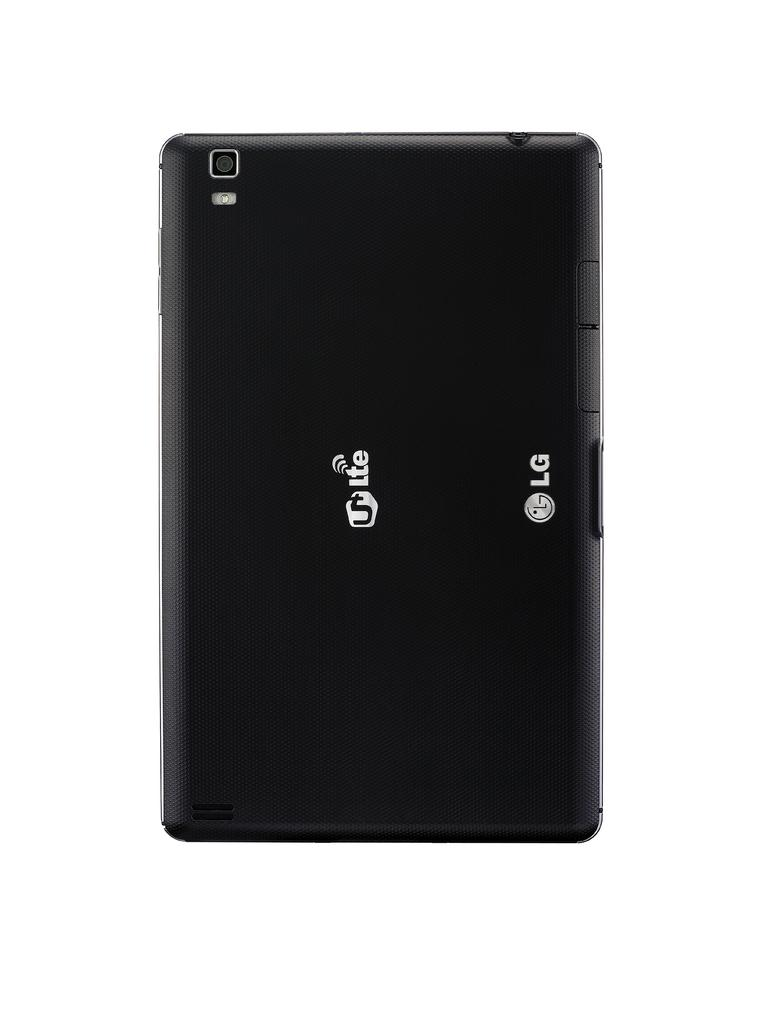Provide a one-sentence caption for the provided image. an LG 5LTE phone on a plain white background. 